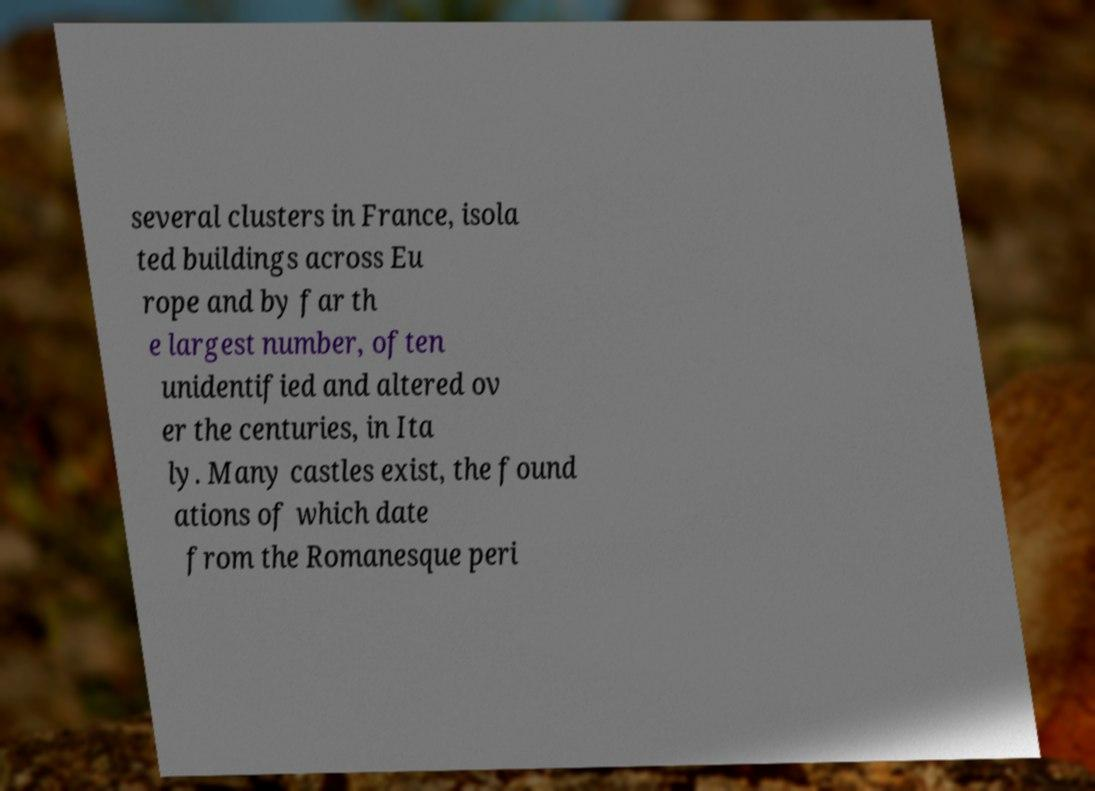There's text embedded in this image that I need extracted. Can you transcribe it verbatim? several clusters in France, isola ted buildings across Eu rope and by far th e largest number, often unidentified and altered ov er the centuries, in Ita ly. Many castles exist, the found ations of which date from the Romanesque peri 